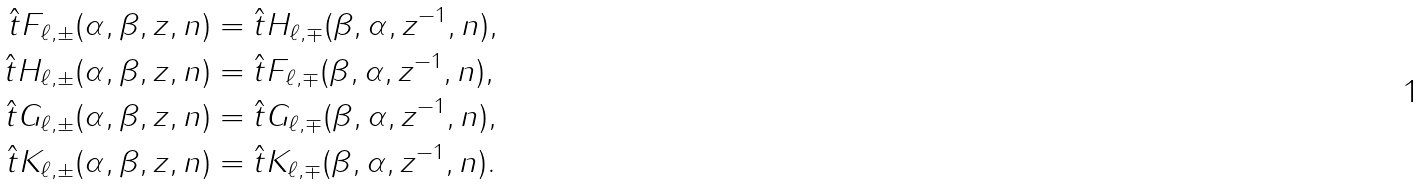Convert formula to latex. <formula><loc_0><loc_0><loc_500><loc_500>\hat { t } F _ { \ell , \pm } ( \alpha , \beta , z , n ) & = \hat { t } H _ { \ell , \mp } ( \beta , \alpha , z ^ { - 1 } , n ) , \\ \hat { t } H _ { \ell , \pm } ( \alpha , \beta , z , n ) & = \hat { t } F _ { \ell , \mp } ( \beta , \alpha , z ^ { - 1 } , n ) , \\ \hat { t } G _ { \ell , \pm } ( \alpha , \beta , z , n ) & = \hat { t } G _ { \ell , \mp } ( \beta , \alpha , z ^ { - 1 } , n ) , \\ \hat { t } K _ { \ell , \pm } ( \alpha , \beta , z , n ) & = \hat { t } K _ { \ell , \mp } ( \beta , \alpha , z ^ { - 1 } , n ) .</formula> 